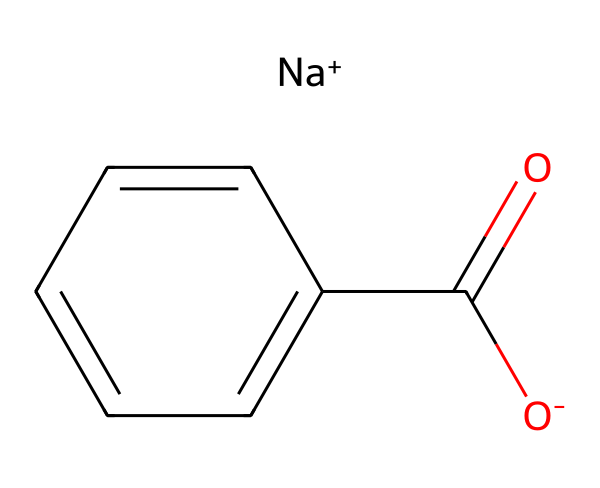What is the chemical name represented by this structure? The structure shown is sodium benzoate, which is a sodium salt of benzoic acid. The presence of the benzoate ion (C(=O)c1ccccc1) suggests it is derived from benzoic acid by replacing a hydrogen atom with a sodium ion.
Answer: sodium benzoate How many carbon atoms are present in the structure? By examining the structure, we see that there are seven carbon atoms in total: one in the carboxylate group and six in the benzene ring.
Answer: seven What type of ion is present in this chemical structure? The structure contains a sodium ion (Na+), which indicates that it is a salt. This ion has a positive charge, signifying its role in balancing the negative charge from the carboxylate group (O-).
Answer: sodium ion What is the functional group present in sodium benzoate? The functional group present is a carboxylate group (C(=O)O-), which is identified by the carbon double-bonded to oxygen and single-bonded to an oxygen atom. This contributes to its preservative properties.
Answer: carboxylate How does sodium benzoate act as a preservative? Sodium benzoate inhibits the growth of mold, yeast, and some bacteria by lowering the pH in foods, which helps to preserve their shelf life. This effect is tied to its carboxylate structure, which can engage with microbial cell membranes.
Answer: by inhibiting microbial growth 